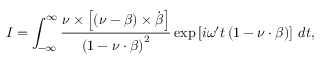Convert formula to latex. <formula><loc_0><loc_0><loc_500><loc_500>I = \int _ { - \infty } ^ { \infty } \frac { \nu \times \left [ \left ( \nu - \beta \right ) \times \dot { \beta } \right ] } { \left ( 1 - \nu \cdot \beta \right ) ^ { 2 } } \exp \left [ i \omega ^ { \prime } t \left ( 1 - \nu \cdot \beta \right ) \right ] \, d t ,</formula> 